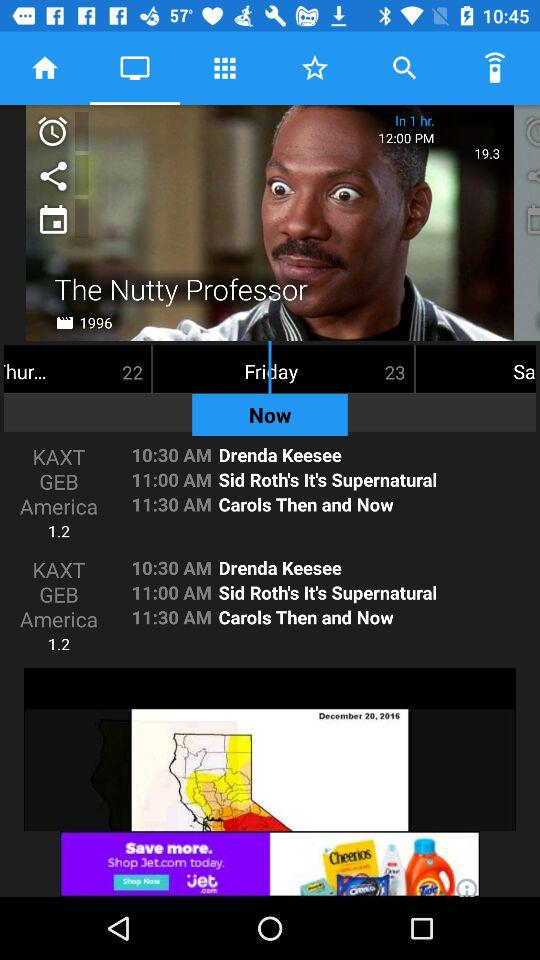How much time is left to telecast "The Nutty Professor"? There is 1 hour left to telecast "The Nutty Professor". 